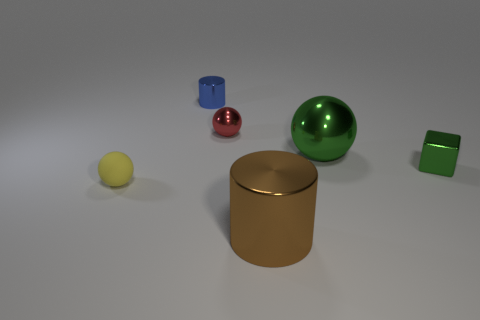There is a sphere right of the big brown metal thing; what color is it?
Give a very brief answer. Green. There is a large shiny thing that is right of the brown metal thing; what number of small red metal things are in front of it?
Ensure brevity in your answer.  0. Is there a tiny blue metallic thing of the same shape as the tiny green metal object?
Ensure brevity in your answer.  No. Do the metal cylinder in front of the small red metal ball and the green thing to the right of the big green object have the same size?
Give a very brief answer. No. What shape is the big thing to the left of the big thing behind the metallic block?
Provide a short and direct response. Cylinder. What number of blue shiny cylinders are the same size as the green metal sphere?
Your response must be concise. 0. Are there any small green things?
Your answer should be very brief. Yes. Is there any other thing that has the same color as the tiny metallic ball?
Give a very brief answer. No. There is a brown object that is made of the same material as the blue object; what shape is it?
Keep it short and to the point. Cylinder. The cylinder left of the cylinder that is in front of the shiny ball to the left of the big brown thing is what color?
Your answer should be compact. Blue. 